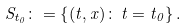<formula> <loc_0><loc_0><loc_500><loc_500>S _ { t _ { 0 } } \colon = \left \{ ( t , x ) \colon \, t = t _ { 0 } \right \} .</formula> 